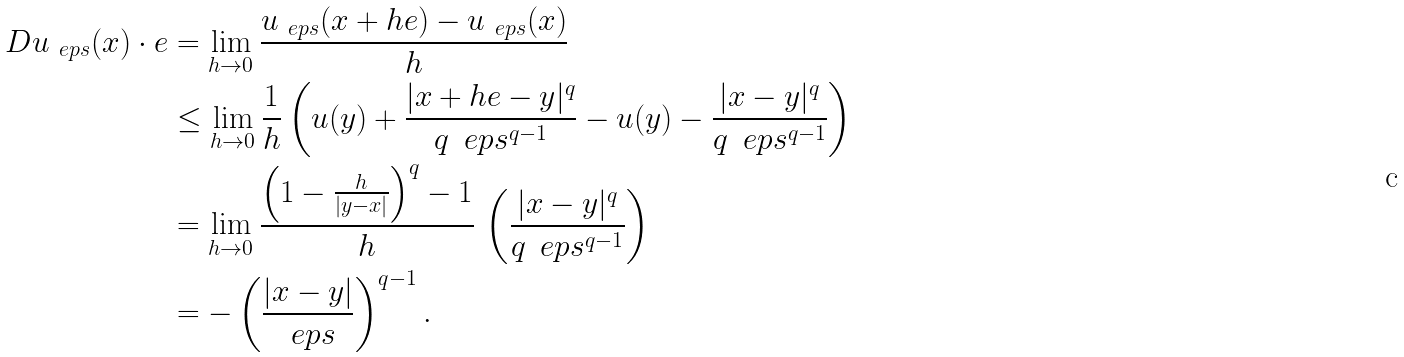Convert formula to latex. <formula><loc_0><loc_0><loc_500><loc_500>D u _ { \ e p s } ( x ) \cdot e & = \lim _ { h \to 0 } \frac { u _ { \ e p s } ( x + h e ) - u _ { \ e p s } ( x ) } { h } \\ & \leq \lim _ { h \to 0 } \frac { 1 } { h } \left ( u ( y ) + \frac { | x + h e - y | ^ { q } } { q \, \ e p s ^ { q - 1 } } - u ( y ) - \frac { | x - y | ^ { q } } { q \, \ e p s ^ { q - 1 } } \right ) \\ & = \lim _ { h \to 0 } \frac { \left ( 1 - \frac { h } { | y - x | } \right ) ^ { q } - 1 } { h } \, \left ( \frac { | x - y | ^ { q } } { q \, \ e p s ^ { q - 1 } } \right ) \\ & = - \left ( \frac { | x - y | } { \ e p s } \right ) ^ { q - 1 } .</formula> 